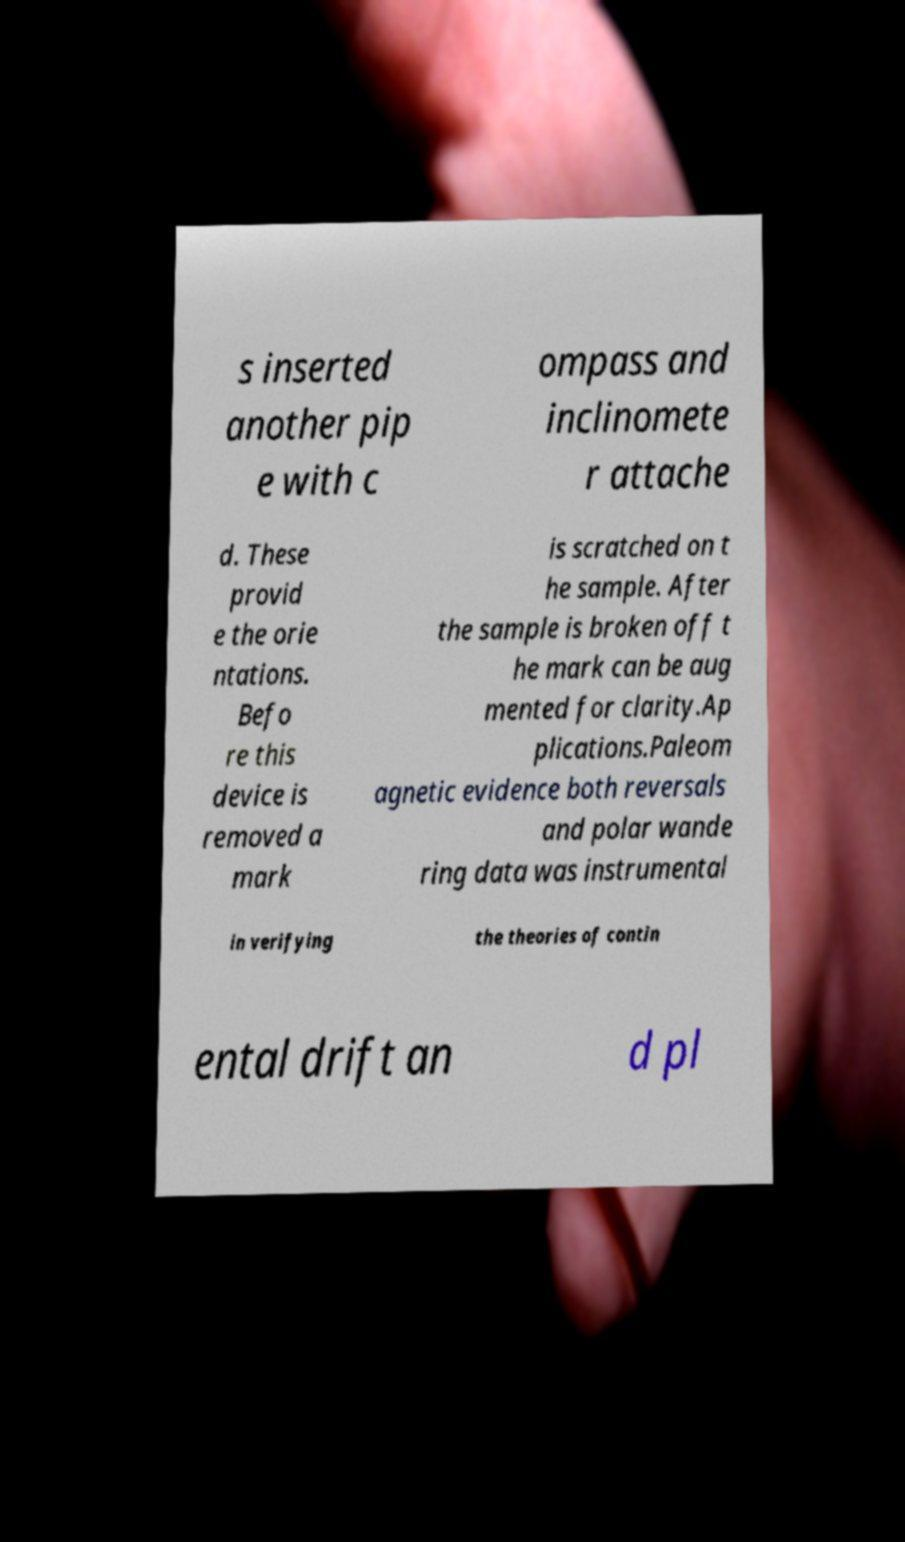Could you extract and type out the text from this image? s inserted another pip e with c ompass and inclinomete r attache d. These provid e the orie ntations. Befo re this device is removed a mark is scratched on t he sample. After the sample is broken off t he mark can be aug mented for clarity.Ap plications.Paleom agnetic evidence both reversals and polar wande ring data was instrumental in verifying the theories of contin ental drift an d pl 